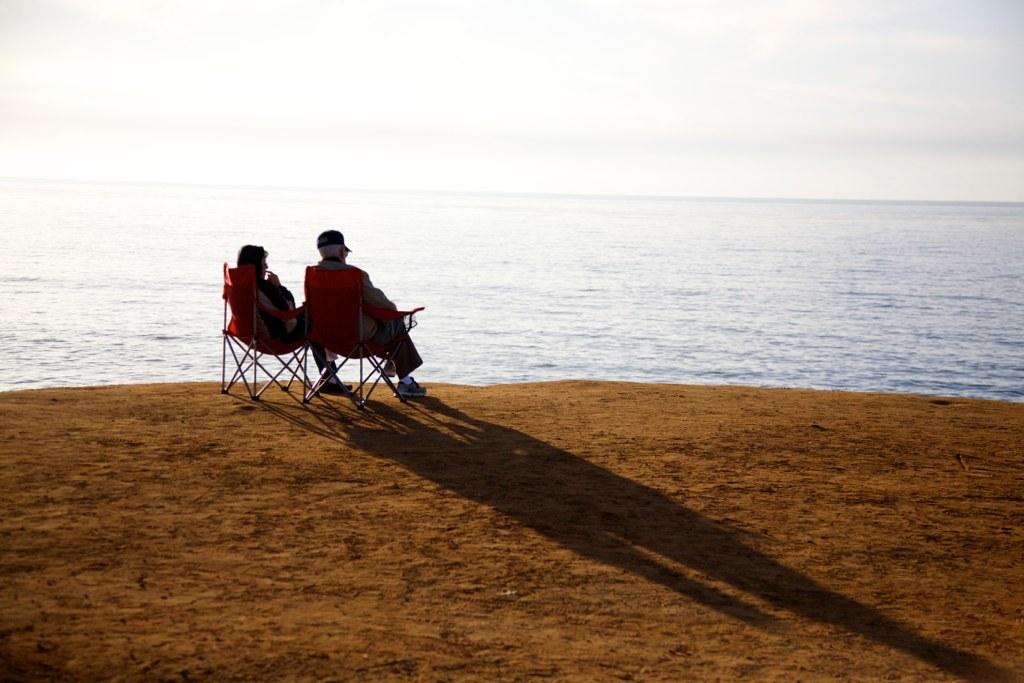How many people are in the image? There are two persons in the image. What are the persons doing in the image? The persons are sitting on chairs. What can be seen in the background of the image? There is water and sky visible in the image. Where are the persons sitting in relation to the water? The persons are sitting on land. What type of engine is visible in the image? There is no engine present in the image. How does the image make you feel in terms of hope or shame? The image does not evoke feelings of hope or shame, as it only depicts two persons sitting on chairs with water and sky in the background. 